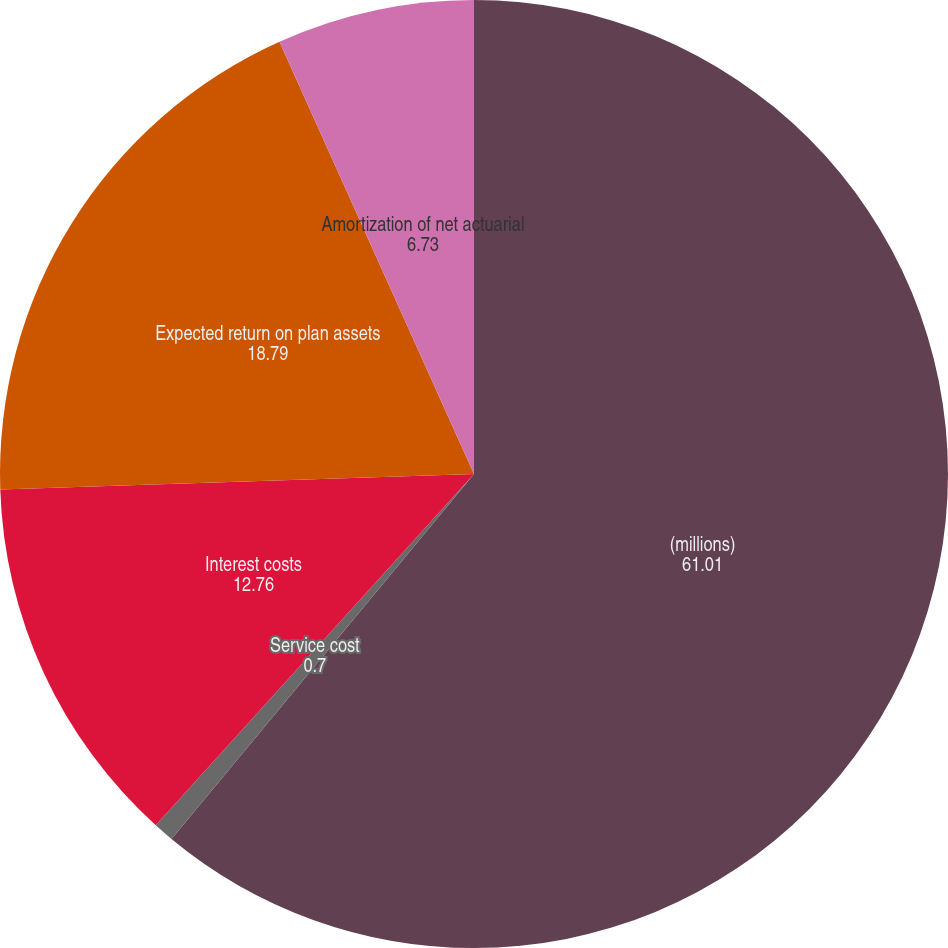<chart> <loc_0><loc_0><loc_500><loc_500><pie_chart><fcel>(millions)<fcel>Service cost<fcel>Interest costs<fcel>Expected return on plan assets<fcel>Amortization of net actuarial<nl><fcel>61.01%<fcel>0.7%<fcel>12.76%<fcel>18.79%<fcel>6.73%<nl></chart> 